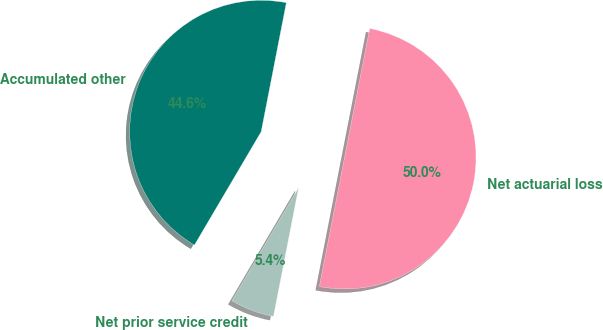Convert chart. <chart><loc_0><loc_0><loc_500><loc_500><pie_chart><fcel>Net prior service credit<fcel>Net actuarial loss<fcel>Accumulated other<nl><fcel>5.4%<fcel>50.0%<fcel>44.6%<nl></chart> 